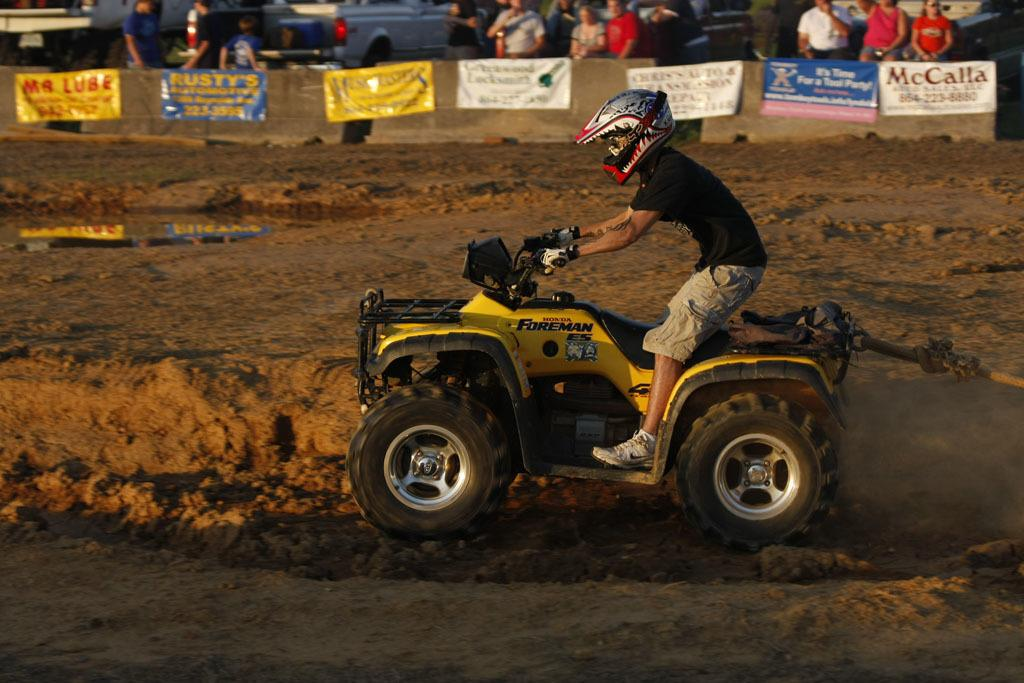What is the main subject of the image? There is a man in the image. What is the man doing in the image? The man is driving a vehicle. What color is the vehicle the man is driving? The vehicle is yellow. What is the man wearing in the image? The man is wearing a black t-shirt. What trade does the man in the image practice? There is no information about the man's trade in the image. Can you solve the riddle that is present in the image? There is no riddle present in the image. 